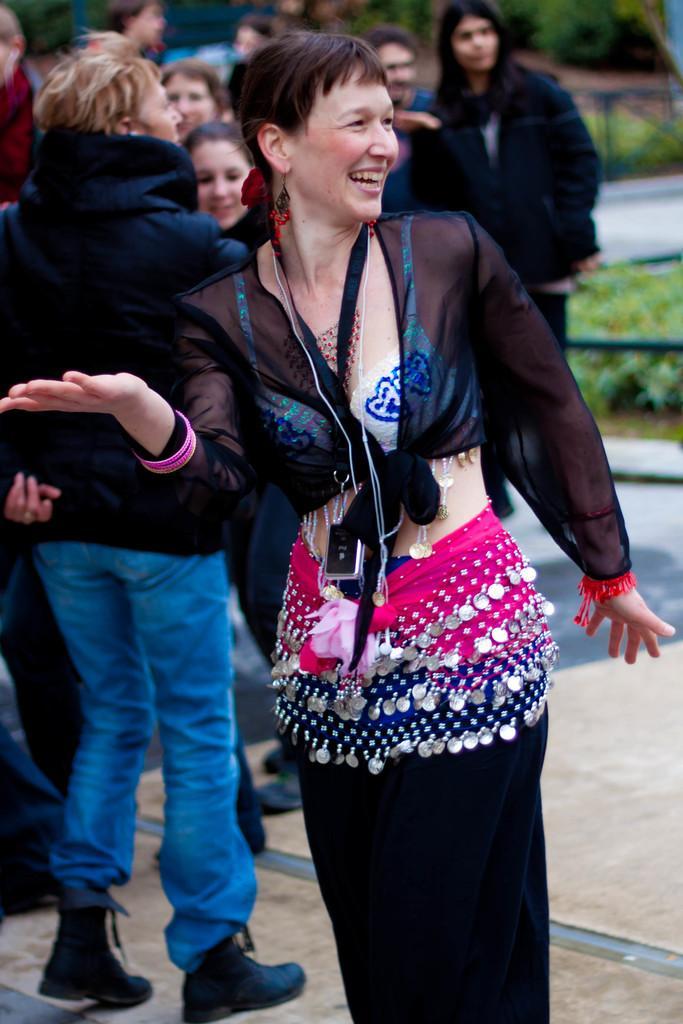Describe this image in one or two sentences. In this picture I can see in the middle a woman is smiling, in the background few people are there. On the right side there are plants. 